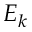Convert formula to latex. <formula><loc_0><loc_0><loc_500><loc_500>E _ { k }</formula> 